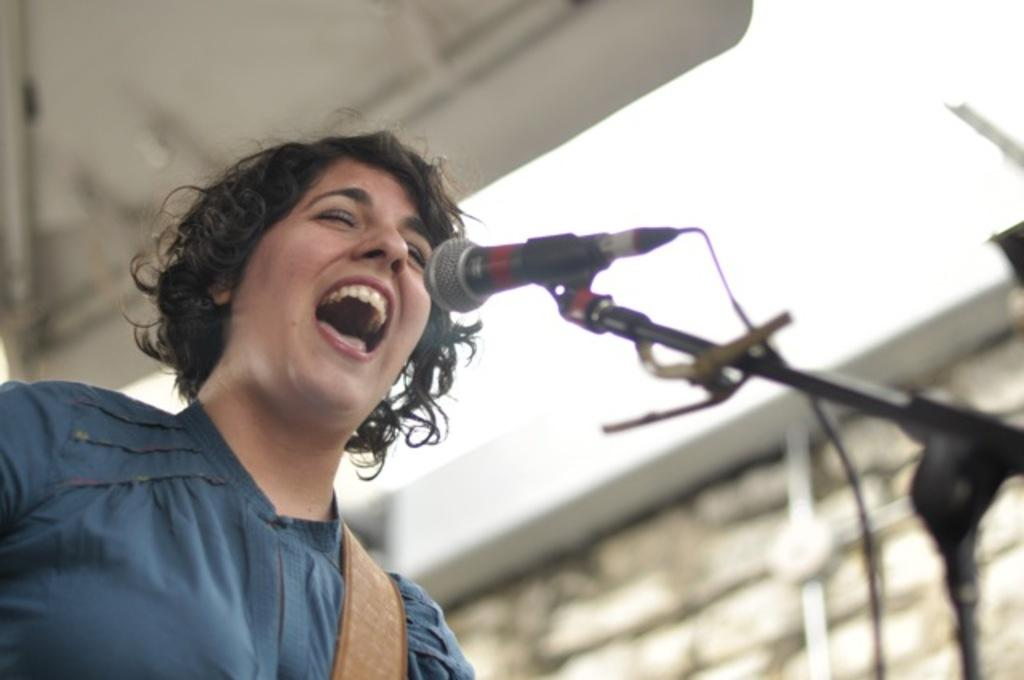Who or what is present in the image? There is a person in the image. What object is associated with the person in the image? There is a microphone (mike) in the image. What is the microphone attached to in the image? There is a microphone stand in the image. Can you describe the background of the image? The background of the image is blurred. What type of alarm can be heard going off in the image? There is no alarm present in the image, and therefore no sound can be heard. 